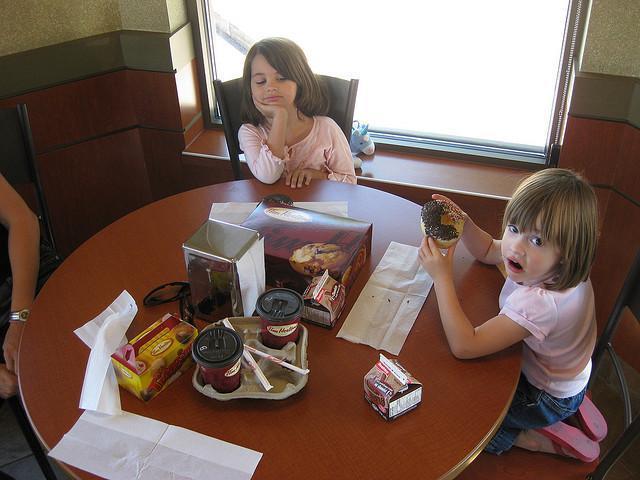How many cups are there?
Give a very brief answer. 2. How many chairs are there?
Give a very brief answer. 4. How many people are in the photo?
Give a very brief answer. 3. 